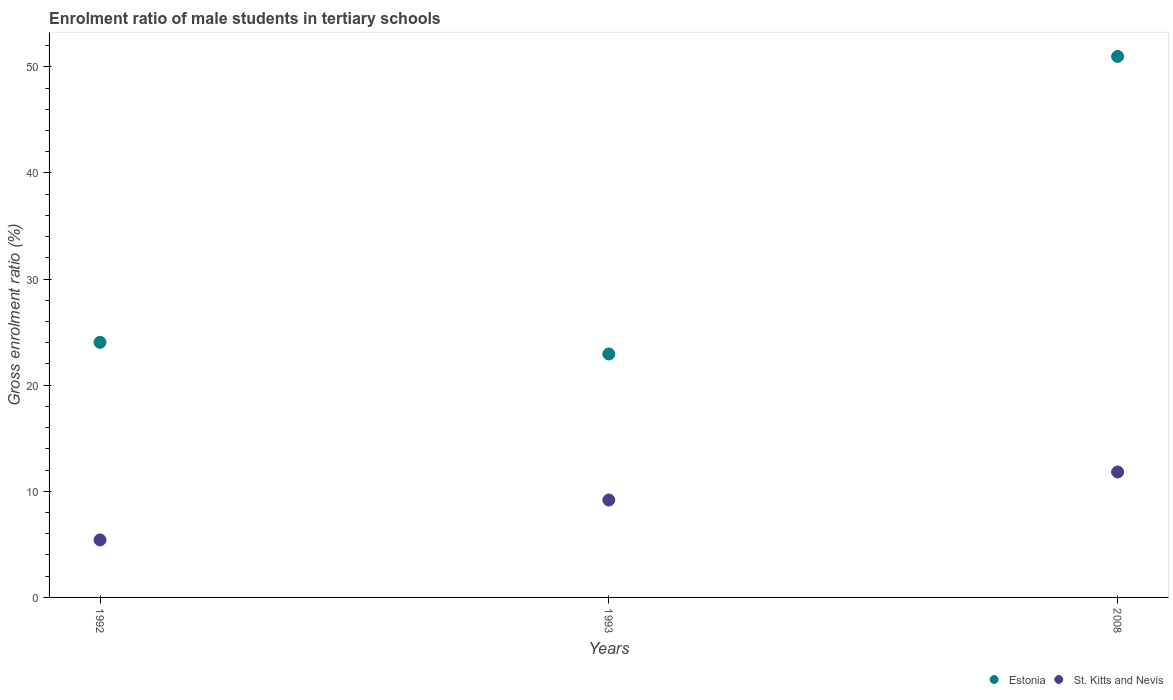What is the enrolment ratio of male students in tertiary schools in Estonia in 1992?
Give a very brief answer. 24.04. Across all years, what is the maximum enrolment ratio of male students in tertiary schools in Estonia?
Ensure brevity in your answer.  50.98. Across all years, what is the minimum enrolment ratio of male students in tertiary schools in St. Kitts and Nevis?
Give a very brief answer. 5.42. In which year was the enrolment ratio of male students in tertiary schools in Estonia maximum?
Your response must be concise. 2008. In which year was the enrolment ratio of male students in tertiary schools in St. Kitts and Nevis minimum?
Provide a succinct answer. 1992. What is the total enrolment ratio of male students in tertiary schools in Estonia in the graph?
Offer a very short reply. 97.97. What is the difference between the enrolment ratio of male students in tertiary schools in St. Kitts and Nevis in 1993 and that in 2008?
Your response must be concise. -2.64. What is the difference between the enrolment ratio of male students in tertiary schools in St. Kitts and Nevis in 1993 and the enrolment ratio of male students in tertiary schools in Estonia in 2008?
Your answer should be compact. -41.8. What is the average enrolment ratio of male students in tertiary schools in St. Kitts and Nevis per year?
Your answer should be very brief. 8.81. In the year 1993, what is the difference between the enrolment ratio of male students in tertiary schools in St. Kitts and Nevis and enrolment ratio of male students in tertiary schools in Estonia?
Provide a short and direct response. -13.76. In how many years, is the enrolment ratio of male students in tertiary schools in St. Kitts and Nevis greater than 36 %?
Ensure brevity in your answer.  0. What is the ratio of the enrolment ratio of male students in tertiary schools in Estonia in 1992 to that in 2008?
Keep it short and to the point. 0.47. Is the difference between the enrolment ratio of male students in tertiary schools in St. Kitts and Nevis in 1992 and 1993 greater than the difference between the enrolment ratio of male students in tertiary schools in Estonia in 1992 and 1993?
Your response must be concise. No. What is the difference between the highest and the second highest enrolment ratio of male students in tertiary schools in St. Kitts and Nevis?
Provide a succinct answer. 2.64. What is the difference between the highest and the lowest enrolment ratio of male students in tertiary schools in St. Kitts and Nevis?
Your answer should be very brief. 6.4. In how many years, is the enrolment ratio of male students in tertiary schools in Estonia greater than the average enrolment ratio of male students in tertiary schools in Estonia taken over all years?
Offer a terse response. 1. Does the enrolment ratio of male students in tertiary schools in St. Kitts and Nevis monotonically increase over the years?
Provide a short and direct response. Yes. Is the enrolment ratio of male students in tertiary schools in Estonia strictly greater than the enrolment ratio of male students in tertiary schools in St. Kitts and Nevis over the years?
Keep it short and to the point. Yes. Is the enrolment ratio of male students in tertiary schools in St. Kitts and Nevis strictly less than the enrolment ratio of male students in tertiary schools in Estonia over the years?
Provide a succinct answer. Yes. How many dotlines are there?
Provide a succinct answer. 2. How many years are there in the graph?
Make the answer very short. 3. Are the values on the major ticks of Y-axis written in scientific E-notation?
Keep it short and to the point. No. Does the graph contain any zero values?
Offer a terse response. No. Does the graph contain grids?
Ensure brevity in your answer.  No. Where does the legend appear in the graph?
Keep it short and to the point. Bottom right. How many legend labels are there?
Your response must be concise. 2. What is the title of the graph?
Offer a very short reply. Enrolment ratio of male students in tertiary schools. Does "Sierra Leone" appear as one of the legend labels in the graph?
Offer a very short reply. No. What is the label or title of the X-axis?
Provide a short and direct response. Years. What is the Gross enrolment ratio (%) in Estonia in 1992?
Your answer should be compact. 24.04. What is the Gross enrolment ratio (%) of St. Kitts and Nevis in 1992?
Your response must be concise. 5.42. What is the Gross enrolment ratio (%) of Estonia in 1993?
Your answer should be compact. 22.94. What is the Gross enrolment ratio (%) of St. Kitts and Nevis in 1993?
Your response must be concise. 9.18. What is the Gross enrolment ratio (%) of Estonia in 2008?
Make the answer very short. 50.98. What is the Gross enrolment ratio (%) of St. Kitts and Nevis in 2008?
Your response must be concise. 11.82. Across all years, what is the maximum Gross enrolment ratio (%) in Estonia?
Your answer should be compact. 50.98. Across all years, what is the maximum Gross enrolment ratio (%) of St. Kitts and Nevis?
Provide a short and direct response. 11.82. Across all years, what is the minimum Gross enrolment ratio (%) of Estonia?
Make the answer very short. 22.94. Across all years, what is the minimum Gross enrolment ratio (%) in St. Kitts and Nevis?
Make the answer very short. 5.42. What is the total Gross enrolment ratio (%) in Estonia in the graph?
Your answer should be very brief. 97.97. What is the total Gross enrolment ratio (%) of St. Kitts and Nevis in the graph?
Keep it short and to the point. 26.42. What is the difference between the Gross enrolment ratio (%) of Estonia in 1992 and that in 1993?
Provide a short and direct response. 1.1. What is the difference between the Gross enrolment ratio (%) in St. Kitts and Nevis in 1992 and that in 1993?
Provide a succinct answer. -3.76. What is the difference between the Gross enrolment ratio (%) in Estonia in 1992 and that in 2008?
Your answer should be compact. -26.94. What is the difference between the Gross enrolment ratio (%) of St. Kitts and Nevis in 1992 and that in 2008?
Your response must be concise. -6.4. What is the difference between the Gross enrolment ratio (%) in Estonia in 1993 and that in 2008?
Keep it short and to the point. -28.04. What is the difference between the Gross enrolment ratio (%) in St. Kitts and Nevis in 1993 and that in 2008?
Offer a terse response. -2.64. What is the difference between the Gross enrolment ratio (%) in Estonia in 1992 and the Gross enrolment ratio (%) in St. Kitts and Nevis in 1993?
Your answer should be very brief. 14.86. What is the difference between the Gross enrolment ratio (%) of Estonia in 1992 and the Gross enrolment ratio (%) of St. Kitts and Nevis in 2008?
Keep it short and to the point. 12.22. What is the difference between the Gross enrolment ratio (%) in Estonia in 1993 and the Gross enrolment ratio (%) in St. Kitts and Nevis in 2008?
Ensure brevity in your answer.  11.12. What is the average Gross enrolment ratio (%) of Estonia per year?
Provide a succinct answer. 32.66. What is the average Gross enrolment ratio (%) of St. Kitts and Nevis per year?
Provide a succinct answer. 8.81. In the year 1992, what is the difference between the Gross enrolment ratio (%) of Estonia and Gross enrolment ratio (%) of St. Kitts and Nevis?
Your answer should be very brief. 18.62. In the year 1993, what is the difference between the Gross enrolment ratio (%) of Estonia and Gross enrolment ratio (%) of St. Kitts and Nevis?
Your answer should be very brief. 13.76. In the year 2008, what is the difference between the Gross enrolment ratio (%) in Estonia and Gross enrolment ratio (%) in St. Kitts and Nevis?
Keep it short and to the point. 39.16. What is the ratio of the Gross enrolment ratio (%) of Estonia in 1992 to that in 1993?
Give a very brief answer. 1.05. What is the ratio of the Gross enrolment ratio (%) in St. Kitts and Nevis in 1992 to that in 1993?
Make the answer very short. 0.59. What is the ratio of the Gross enrolment ratio (%) in Estonia in 1992 to that in 2008?
Ensure brevity in your answer.  0.47. What is the ratio of the Gross enrolment ratio (%) of St. Kitts and Nevis in 1992 to that in 2008?
Ensure brevity in your answer.  0.46. What is the ratio of the Gross enrolment ratio (%) of Estonia in 1993 to that in 2008?
Provide a short and direct response. 0.45. What is the ratio of the Gross enrolment ratio (%) of St. Kitts and Nevis in 1993 to that in 2008?
Your answer should be compact. 0.78. What is the difference between the highest and the second highest Gross enrolment ratio (%) in Estonia?
Your answer should be compact. 26.94. What is the difference between the highest and the second highest Gross enrolment ratio (%) of St. Kitts and Nevis?
Provide a succinct answer. 2.64. What is the difference between the highest and the lowest Gross enrolment ratio (%) in Estonia?
Provide a short and direct response. 28.04. What is the difference between the highest and the lowest Gross enrolment ratio (%) of St. Kitts and Nevis?
Your answer should be compact. 6.4. 